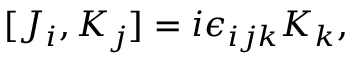<formula> <loc_0><loc_0><loc_500><loc_500>[ J _ { i } , K _ { j } ] = i \epsilon _ { i j k } K _ { k } ,</formula> 